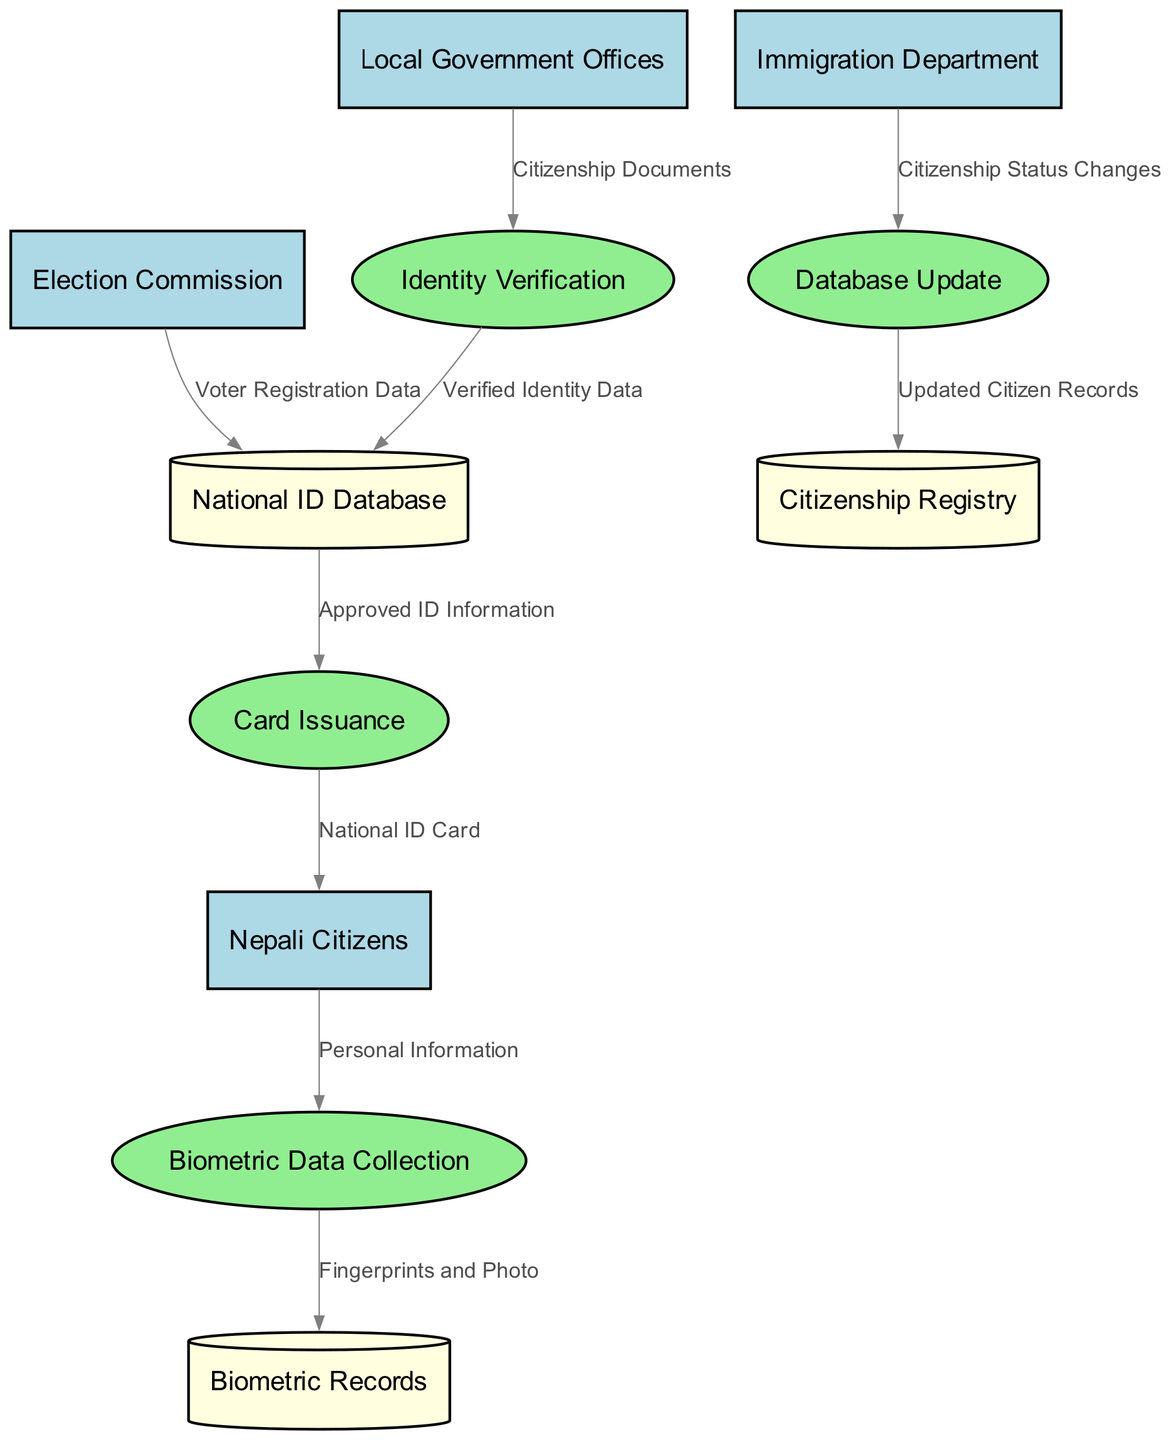What is the number of external entities in the diagram? The diagram lists four external entities: Nepali Citizens, Local Government Offices, Immigration Department, and Election Commission. Therefore, the count of external entities is determined by enumerating these entities.
Answer: 4 Which process receives fingerprints and photo data? The data flow diagram indicates that the Biometric Data Collection process is where the fingerprints and photo data are directed after collection from Nepali Citizens. This is based on the arrow showing data flow from Biometric Data Collection to Biometric Records.
Answer: Biometric Data Collection From which external entity does the National ID Database receive verified identity data? The diagram shows that the verified identity data flows from the Identity Verification process to the National ID Database. The Identity Verification process, in turn, receives citizenship documents from Local Government Offices, indicating that the verified identity data originates from this external entity.
Answer: Local Government Offices How many processes are involved in the national identity card program? The diagram details four distinct processes: Biometric Data Collection, Identity Verification, Card Issuance, and Database Update. By counting these processes, we can determine the total number involved in the program's operations.
Answer: 4 What type of data does the Election Commission send to the National ID Database? According to the data flow diagram, the Election Commission sends Voter Registration Data to the National ID Database. This is illustrated by the directed edge connecting these two nodes.
Answer: Voter Registration Data Which data store receives updated citizen records? The diagram specifies that updated citizen records are directed to the Citizenship Registry from the Database Update process. This information is captured through the flow indicated between these two components in the diagram.
Answer: Citizenship Registry What type of information is issued to Nepali Citizens? The final process labeled Card Issuance produces the National ID Card for Nepali Citizens according to the flow indicated in the diagram. This is determined by the arrow connecting Card Issuance to Nepali Citizens, labeled with "National ID Card."
Answer: National ID Card Which process follows after the Identity Verification process? The flow of data indicates that once identity verification is complete, the process that follows is the updating of the National ID Database with Verified Identity Data. This is demonstrated by the directed edge from Identity Verification to National ID Database.
Answer: Database Update Which process receives data from the Immigration Department? Based on the data flow diagram, the Database Update process receives Citizenship Status Changes data from the Immigration Department, as indicated by the arrow connecting these two entities.
Answer: Database Update 